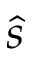<formula> <loc_0><loc_0><loc_500><loc_500>\hat { s }</formula> 